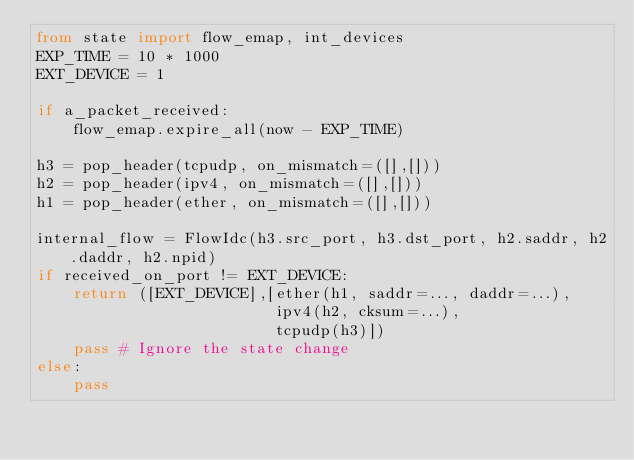Convert code to text. <code><loc_0><loc_0><loc_500><loc_500><_Python_>from state import flow_emap, int_devices
EXP_TIME = 10 * 1000
EXT_DEVICE = 1

if a_packet_received:
    flow_emap.expire_all(now - EXP_TIME)

h3 = pop_header(tcpudp, on_mismatch=([],[]))
h2 = pop_header(ipv4, on_mismatch=([],[]))
h1 = pop_header(ether, on_mismatch=([],[]))

internal_flow = FlowIdc(h3.src_port, h3.dst_port, h2.saddr, h2.daddr, h2.npid)
if received_on_port != EXT_DEVICE:
    return ([EXT_DEVICE],[ether(h1, saddr=..., daddr=...),
                          ipv4(h2, cksum=...),
                          tcpudp(h3)])
    pass # Ignore the state change
else:
    pass
</code> 